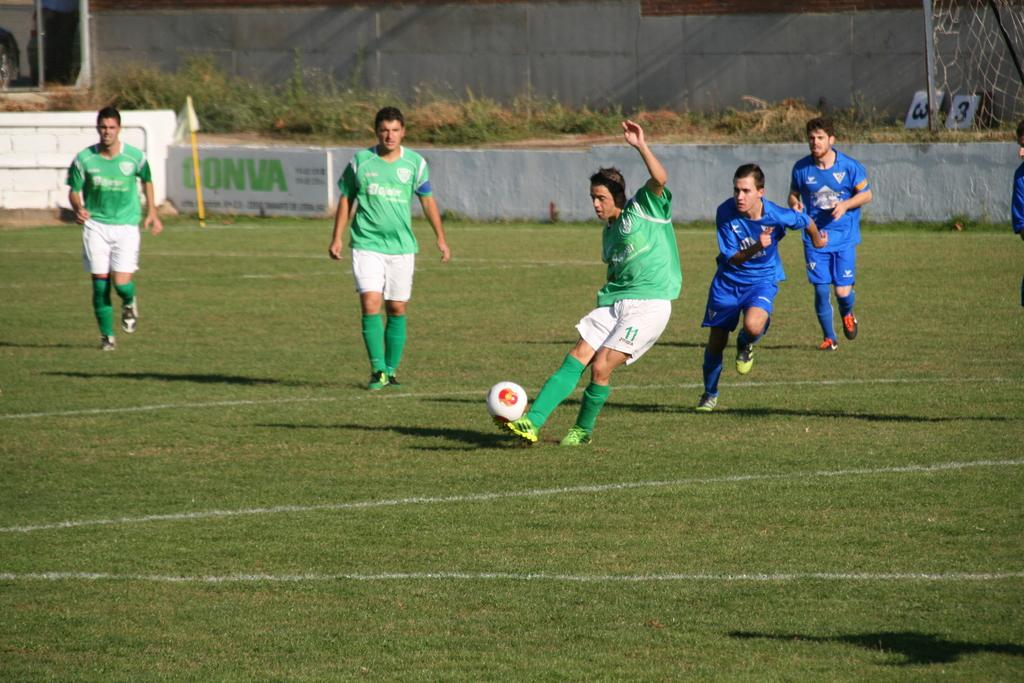<image>
Create a compact narrative representing the image presented. A soccer player with a number 11 on his uniform is currently in control of the ball. 